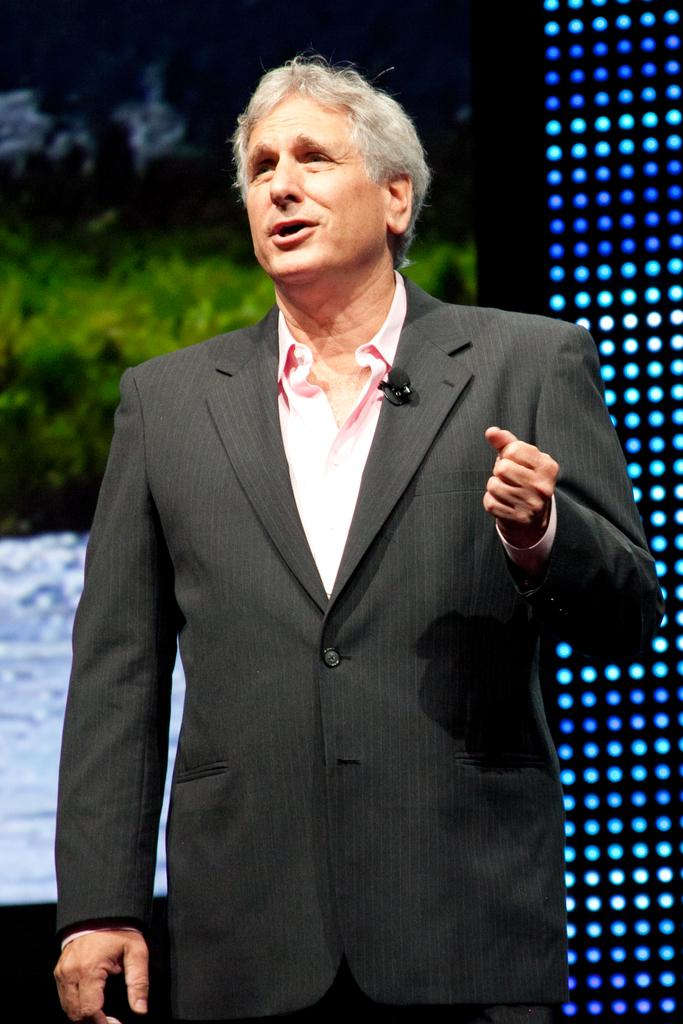Who or what is in the image? There is a person in the image. What is behind the person? There is a screen behind the person. Where are the lights located in the image? The lights are on the right side of the image. What type of story is being told by the person in the image? There is no indication of a story being told in the image; it only shows a person with a screen behind them and lights on the right side. 